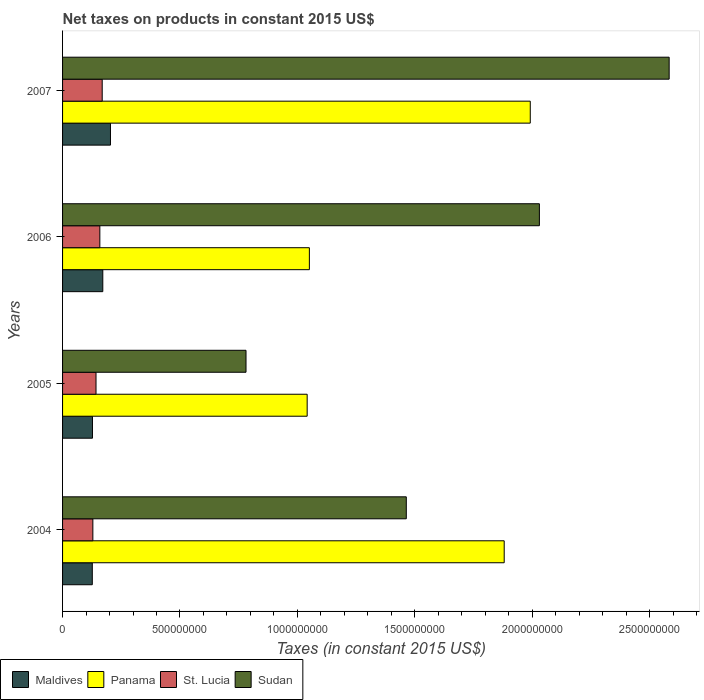How many groups of bars are there?
Your answer should be very brief. 4. Are the number of bars on each tick of the Y-axis equal?
Your response must be concise. Yes. In how many cases, is the number of bars for a given year not equal to the number of legend labels?
Make the answer very short. 0. What is the net taxes on products in St. Lucia in 2004?
Provide a short and direct response. 1.29e+08. Across all years, what is the maximum net taxes on products in Panama?
Provide a succinct answer. 1.99e+09. Across all years, what is the minimum net taxes on products in St. Lucia?
Keep it short and to the point. 1.29e+08. In which year was the net taxes on products in Panama maximum?
Your answer should be compact. 2007. What is the total net taxes on products in Panama in the graph?
Keep it short and to the point. 5.97e+09. What is the difference between the net taxes on products in Panama in 2005 and that in 2007?
Offer a terse response. -9.50e+08. What is the difference between the net taxes on products in Panama in 2006 and the net taxes on products in Maldives in 2005?
Keep it short and to the point. 9.24e+08. What is the average net taxes on products in Panama per year?
Your answer should be compact. 1.49e+09. In the year 2005, what is the difference between the net taxes on products in Panama and net taxes on products in St. Lucia?
Your answer should be compact. 8.99e+08. In how many years, is the net taxes on products in Panama greater than 400000000 US$?
Keep it short and to the point. 4. What is the ratio of the net taxes on products in St. Lucia in 2004 to that in 2006?
Offer a terse response. 0.81. Is the difference between the net taxes on products in Panama in 2004 and 2006 greater than the difference between the net taxes on products in St. Lucia in 2004 and 2006?
Give a very brief answer. Yes. What is the difference between the highest and the second highest net taxes on products in Panama?
Provide a short and direct response. 1.11e+08. What is the difference between the highest and the lowest net taxes on products in St. Lucia?
Give a very brief answer. 3.98e+07. Is the sum of the net taxes on products in Panama in 2004 and 2006 greater than the maximum net taxes on products in Sudan across all years?
Your answer should be compact. Yes. What does the 4th bar from the top in 2004 represents?
Provide a short and direct response. Maldives. What does the 1st bar from the bottom in 2006 represents?
Offer a terse response. Maldives. How many bars are there?
Give a very brief answer. 16. Are all the bars in the graph horizontal?
Provide a short and direct response. Yes. What is the difference between two consecutive major ticks on the X-axis?
Your answer should be compact. 5.00e+08. Are the values on the major ticks of X-axis written in scientific E-notation?
Offer a terse response. No. Where does the legend appear in the graph?
Your answer should be compact. Bottom left. How are the legend labels stacked?
Ensure brevity in your answer.  Horizontal. What is the title of the graph?
Provide a succinct answer. Net taxes on products in constant 2015 US$. Does "Mali" appear as one of the legend labels in the graph?
Make the answer very short. No. What is the label or title of the X-axis?
Your answer should be very brief. Taxes (in constant 2015 US$). What is the label or title of the Y-axis?
Keep it short and to the point. Years. What is the Taxes (in constant 2015 US$) in Maldives in 2004?
Provide a succinct answer. 1.27e+08. What is the Taxes (in constant 2015 US$) of Panama in 2004?
Your response must be concise. 1.88e+09. What is the Taxes (in constant 2015 US$) of St. Lucia in 2004?
Provide a succinct answer. 1.29e+08. What is the Taxes (in constant 2015 US$) of Sudan in 2004?
Keep it short and to the point. 1.46e+09. What is the Taxes (in constant 2015 US$) in Maldives in 2005?
Provide a succinct answer. 1.27e+08. What is the Taxes (in constant 2015 US$) in Panama in 2005?
Offer a terse response. 1.04e+09. What is the Taxes (in constant 2015 US$) in St. Lucia in 2005?
Offer a very short reply. 1.42e+08. What is the Taxes (in constant 2015 US$) in Sudan in 2005?
Your answer should be very brief. 7.81e+08. What is the Taxes (in constant 2015 US$) of Maldives in 2006?
Keep it short and to the point. 1.71e+08. What is the Taxes (in constant 2015 US$) in Panama in 2006?
Provide a short and direct response. 1.05e+09. What is the Taxes (in constant 2015 US$) in St. Lucia in 2006?
Keep it short and to the point. 1.59e+08. What is the Taxes (in constant 2015 US$) of Sudan in 2006?
Offer a very short reply. 2.03e+09. What is the Taxes (in constant 2015 US$) of Maldives in 2007?
Your answer should be very brief. 2.04e+08. What is the Taxes (in constant 2015 US$) in Panama in 2007?
Your answer should be very brief. 1.99e+09. What is the Taxes (in constant 2015 US$) in St. Lucia in 2007?
Your answer should be very brief. 1.69e+08. What is the Taxes (in constant 2015 US$) of Sudan in 2007?
Your answer should be very brief. 2.58e+09. Across all years, what is the maximum Taxes (in constant 2015 US$) of Maldives?
Your answer should be very brief. 2.04e+08. Across all years, what is the maximum Taxes (in constant 2015 US$) of Panama?
Provide a succinct answer. 1.99e+09. Across all years, what is the maximum Taxes (in constant 2015 US$) of St. Lucia?
Keep it short and to the point. 1.69e+08. Across all years, what is the maximum Taxes (in constant 2015 US$) of Sudan?
Your answer should be very brief. 2.58e+09. Across all years, what is the minimum Taxes (in constant 2015 US$) in Maldives?
Offer a very short reply. 1.27e+08. Across all years, what is the minimum Taxes (in constant 2015 US$) in Panama?
Your response must be concise. 1.04e+09. Across all years, what is the minimum Taxes (in constant 2015 US$) of St. Lucia?
Give a very brief answer. 1.29e+08. Across all years, what is the minimum Taxes (in constant 2015 US$) in Sudan?
Offer a very short reply. 7.81e+08. What is the total Taxes (in constant 2015 US$) of Maldives in the graph?
Your response must be concise. 6.29e+08. What is the total Taxes (in constant 2015 US$) of Panama in the graph?
Your answer should be compact. 5.97e+09. What is the total Taxes (in constant 2015 US$) of St. Lucia in the graph?
Provide a short and direct response. 5.99e+08. What is the total Taxes (in constant 2015 US$) of Sudan in the graph?
Your answer should be very brief. 6.86e+09. What is the difference between the Taxes (in constant 2015 US$) in Maldives in 2004 and that in 2005?
Give a very brief answer. -6.98e+05. What is the difference between the Taxes (in constant 2015 US$) in Panama in 2004 and that in 2005?
Offer a very short reply. 8.39e+08. What is the difference between the Taxes (in constant 2015 US$) of St. Lucia in 2004 and that in 2005?
Keep it short and to the point. -1.35e+07. What is the difference between the Taxes (in constant 2015 US$) of Sudan in 2004 and that in 2005?
Give a very brief answer. 6.83e+08. What is the difference between the Taxes (in constant 2015 US$) in Maldives in 2004 and that in 2006?
Your answer should be compact. -4.47e+07. What is the difference between the Taxes (in constant 2015 US$) of Panama in 2004 and that in 2006?
Your response must be concise. 8.30e+08. What is the difference between the Taxes (in constant 2015 US$) of St. Lucia in 2004 and that in 2006?
Offer a very short reply. -2.98e+07. What is the difference between the Taxes (in constant 2015 US$) in Sudan in 2004 and that in 2006?
Provide a succinct answer. -5.67e+08. What is the difference between the Taxes (in constant 2015 US$) of Maldives in 2004 and that in 2007?
Offer a terse response. -7.74e+07. What is the difference between the Taxes (in constant 2015 US$) in Panama in 2004 and that in 2007?
Make the answer very short. -1.11e+08. What is the difference between the Taxes (in constant 2015 US$) of St. Lucia in 2004 and that in 2007?
Your answer should be very brief. -3.98e+07. What is the difference between the Taxes (in constant 2015 US$) in Sudan in 2004 and that in 2007?
Make the answer very short. -1.12e+09. What is the difference between the Taxes (in constant 2015 US$) of Maldives in 2005 and that in 2006?
Offer a very short reply. -4.40e+07. What is the difference between the Taxes (in constant 2015 US$) of Panama in 2005 and that in 2006?
Your answer should be very brief. -9.40e+06. What is the difference between the Taxes (in constant 2015 US$) of St. Lucia in 2005 and that in 2006?
Your response must be concise. -1.63e+07. What is the difference between the Taxes (in constant 2015 US$) in Sudan in 2005 and that in 2006?
Your answer should be very brief. -1.25e+09. What is the difference between the Taxes (in constant 2015 US$) in Maldives in 2005 and that in 2007?
Offer a terse response. -7.67e+07. What is the difference between the Taxes (in constant 2015 US$) in Panama in 2005 and that in 2007?
Provide a succinct answer. -9.50e+08. What is the difference between the Taxes (in constant 2015 US$) of St. Lucia in 2005 and that in 2007?
Provide a succinct answer. -2.63e+07. What is the difference between the Taxes (in constant 2015 US$) of Sudan in 2005 and that in 2007?
Keep it short and to the point. -1.80e+09. What is the difference between the Taxes (in constant 2015 US$) in Maldives in 2006 and that in 2007?
Give a very brief answer. -3.27e+07. What is the difference between the Taxes (in constant 2015 US$) in Panama in 2006 and that in 2007?
Your answer should be very brief. -9.41e+08. What is the difference between the Taxes (in constant 2015 US$) in St. Lucia in 2006 and that in 2007?
Offer a terse response. -1.01e+07. What is the difference between the Taxes (in constant 2015 US$) in Sudan in 2006 and that in 2007?
Offer a terse response. -5.53e+08. What is the difference between the Taxes (in constant 2015 US$) of Maldives in 2004 and the Taxes (in constant 2015 US$) of Panama in 2005?
Ensure brevity in your answer.  -9.15e+08. What is the difference between the Taxes (in constant 2015 US$) of Maldives in 2004 and the Taxes (in constant 2015 US$) of St. Lucia in 2005?
Keep it short and to the point. -1.59e+07. What is the difference between the Taxes (in constant 2015 US$) in Maldives in 2004 and the Taxes (in constant 2015 US$) in Sudan in 2005?
Offer a very short reply. -6.55e+08. What is the difference between the Taxes (in constant 2015 US$) of Panama in 2004 and the Taxes (in constant 2015 US$) of St. Lucia in 2005?
Make the answer very short. 1.74e+09. What is the difference between the Taxes (in constant 2015 US$) of Panama in 2004 and the Taxes (in constant 2015 US$) of Sudan in 2005?
Provide a short and direct response. 1.10e+09. What is the difference between the Taxes (in constant 2015 US$) of St. Lucia in 2004 and the Taxes (in constant 2015 US$) of Sudan in 2005?
Your answer should be compact. -6.52e+08. What is the difference between the Taxes (in constant 2015 US$) in Maldives in 2004 and the Taxes (in constant 2015 US$) in Panama in 2006?
Offer a terse response. -9.25e+08. What is the difference between the Taxes (in constant 2015 US$) of Maldives in 2004 and the Taxes (in constant 2015 US$) of St. Lucia in 2006?
Keep it short and to the point. -3.21e+07. What is the difference between the Taxes (in constant 2015 US$) in Maldives in 2004 and the Taxes (in constant 2015 US$) in Sudan in 2006?
Your answer should be compact. -1.90e+09. What is the difference between the Taxes (in constant 2015 US$) of Panama in 2004 and the Taxes (in constant 2015 US$) of St. Lucia in 2006?
Give a very brief answer. 1.72e+09. What is the difference between the Taxes (in constant 2015 US$) in Panama in 2004 and the Taxes (in constant 2015 US$) in Sudan in 2006?
Your answer should be compact. -1.50e+08. What is the difference between the Taxes (in constant 2015 US$) of St. Lucia in 2004 and the Taxes (in constant 2015 US$) of Sudan in 2006?
Provide a short and direct response. -1.90e+09. What is the difference between the Taxes (in constant 2015 US$) of Maldives in 2004 and the Taxes (in constant 2015 US$) of Panama in 2007?
Your answer should be compact. -1.87e+09. What is the difference between the Taxes (in constant 2015 US$) of Maldives in 2004 and the Taxes (in constant 2015 US$) of St. Lucia in 2007?
Offer a terse response. -4.22e+07. What is the difference between the Taxes (in constant 2015 US$) of Maldives in 2004 and the Taxes (in constant 2015 US$) of Sudan in 2007?
Offer a terse response. -2.46e+09. What is the difference between the Taxes (in constant 2015 US$) of Panama in 2004 and the Taxes (in constant 2015 US$) of St. Lucia in 2007?
Provide a succinct answer. 1.71e+09. What is the difference between the Taxes (in constant 2015 US$) of Panama in 2004 and the Taxes (in constant 2015 US$) of Sudan in 2007?
Your answer should be very brief. -7.03e+08. What is the difference between the Taxes (in constant 2015 US$) of St. Lucia in 2004 and the Taxes (in constant 2015 US$) of Sudan in 2007?
Provide a succinct answer. -2.45e+09. What is the difference between the Taxes (in constant 2015 US$) of Maldives in 2005 and the Taxes (in constant 2015 US$) of Panama in 2006?
Offer a very short reply. -9.24e+08. What is the difference between the Taxes (in constant 2015 US$) in Maldives in 2005 and the Taxes (in constant 2015 US$) in St. Lucia in 2006?
Offer a very short reply. -3.14e+07. What is the difference between the Taxes (in constant 2015 US$) in Maldives in 2005 and the Taxes (in constant 2015 US$) in Sudan in 2006?
Keep it short and to the point. -1.90e+09. What is the difference between the Taxes (in constant 2015 US$) in Panama in 2005 and the Taxes (in constant 2015 US$) in St. Lucia in 2006?
Offer a terse response. 8.83e+08. What is the difference between the Taxes (in constant 2015 US$) in Panama in 2005 and the Taxes (in constant 2015 US$) in Sudan in 2006?
Your response must be concise. -9.89e+08. What is the difference between the Taxes (in constant 2015 US$) of St. Lucia in 2005 and the Taxes (in constant 2015 US$) of Sudan in 2006?
Make the answer very short. -1.89e+09. What is the difference between the Taxes (in constant 2015 US$) in Maldives in 2005 and the Taxes (in constant 2015 US$) in Panama in 2007?
Your response must be concise. -1.86e+09. What is the difference between the Taxes (in constant 2015 US$) in Maldives in 2005 and the Taxes (in constant 2015 US$) in St. Lucia in 2007?
Provide a succinct answer. -4.15e+07. What is the difference between the Taxes (in constant 2015 US$) of Maldives in 2005 and the Taxes (in constant 2015 US$) of Sudan in 2007?
Ensure brevity in your answer.  -2.46e+09. What is the difference between the Taxes (in constant 2015 US$) of Panama in 2005 and the Taxes (in constant 2015 US$) of St. Lucia in 2007?
Provide a succinct answer. 8.73e+08. What is the difference between the Taxes (in constant 2015 US$) in Panama in 2005 and the Taxes (in constant 2015 US$) in Sudan in 2007?
Your answer should be compact. -1.54e+09. What is the difference between the Taxes (in constant 2015 US$) in St. Lucia in 2005 and the Taxes (in constant 2015 US$) in Sudan in 2007?
Ensure brevity in your answer.  -2.44e+09. What is the difference between the Taxes (in constant 2015 US$) in Maldives in 2006 and the Taxes (in constant 2015 US$) in Panama in 2007?
Make the answer very short. -1.82e+09. What is the difference between the Taxes (in constant 2015 US$) in Maldives in 2006 and the Taxes (in constant 2015 US$) in St. Lucia in 2007?
Your answer should be compact. 2.49e+06. What is the difference between the Taxes (in constant 2015 US$) in Maldives in 2006 and the Taxes (in constant 2015 US$) in Sudan in 2007?
Give a very brief answer. -2.41e+09. What is the difference between the Taxes (in constant 2015 US$) in Panama in 2006 and the Taxes (in constant 2015 US$) in St. Lucia in 2007?
Provide a short and direct response. 8.82e+08. What is the difference between the Taxes (in constant 2015 US$) in Panama in 2006 and the Taxes (in constant 2015 US$) in Sudan in 2007?
Your answer should be very brief. -1.53e+09. What is the difference between the Taxes (in constant 2015 US$) in St. Lucia in 2006 and the Taxes (in constant 2015 US$) in Sudan in 2007?
Your response must be concise. -2.42e+09. What is the average Taxes (in constant 2015 US$) of Maldives per year?
Your response must be concise. 1.57e+08. What is the average Taxes (in constant 2015 US$) of Panama per year?
Offer a very short reply. 1.49e+09. What is the average Taxes (in constant 2015 US$) in St. Lucia per year?
Provide a short and direct response. 1.50e+08. What is the average Taxes (in constant 2015 US$) of Sudan per year?
Provide a succinct answer. 1.71e+09. In the year 2004, what is the difference between the Taxes (in constant 2015 US$) of Maldives and Taxes (in constant 2015 US$) of Panama?
Provide a succinct answer. -1.75e+09. In the year 2004, what is the difference between the Taxes (in constant 2015 US$) in Maldives and Taxes (in constant 2015 US$) in St. Lucia?
Your answer should be compact. -2.38e+06. In the year 2004, what is the difference between the Taxes (in constant 2015 US$) in Maldives and Taxes (in constant 2015 US$) in Sudan?
Your response must be concise. -1.34e+09. In the year 2004, what is the difference between the Taxes (in constant 2015 US$) of Panama and Taxes (in constant 2015 US$) of St. Lucia?
Offer a very short reply. 1.75e+09. In the year 2004, what is the difference between the Taxes (in constant 2015 US$) of Panama and Taxes (in constant 2015 US$) of Sudan?
Your answer should be compact. 4.17e+08. In the year 2004, what is the difference between the Taxes (in constant 2015 US$) in St. Lucia and Taxes (in constant 2015 US$) in Sudan?
Ensure brevity in your answer.  -1.34e+09. In the year 2005, what is the difference between the Taxes (in constant 2015 US$) in Maldives and Taxes (in constant 2015 US$) in Panama?
Offer a very short reply. -9.14e+08. In the year 2005, what is the difference between the Taxes (in constant 2015 US$) in Maldives and Taxes (in constant 2015 US$) in St. Lucia?
Offer a very short reply. -1.52e+07. In the year 2005, what is the difference between the Taxes (in constant 2015 US$) of Maldives and Taxes (in constant 2015 US$) of Sudan?
Your answer should be very brief. -6.54e+08. In the year 2005, what is the difference between the Taxes (in constant 2015 US$) of Panama and Taxes (in constant 2015 US$) of St. Lucia?
Offer a terse response. 8.99e+08. In the year 2005, what is the difference between the Taxes (in constant 2015 US$) in Panama and Taxes (in constant 2015 US$) in Sudan?
Offer a terse response. 2.60e+08. In the year 2005, what is the difference between the Taxes (in constant 2015 US$) of St. Lucia and Taxes (in constant 2015 US$) of Sudan?
Provide a short and direct response. -6.39e+08. In the year 2006, what is the difference between the Taxes (in constant 2015 US$) of Maldives and Taxes (in constant 2015 US$) of Panama?
Offer a very short reply. -8.80e+08. In the year 2006, what is the difference between the Taxes (in constant 2015 US$) in Maldives and Taxes (in constant 2015 US$) in St. Lucia?
Provide a short and direct response. 1.25e+07. In the year 2006, what is the difference between the Taxes (in constant 2015 US$) of Maldives and Taxes (in constant 2015 US$) of Sudan?
Make the answer very short. -1.86e+09. In the year 2006, what is the difference between the Taxes (in constant 2015 US$) of Panama and Taxes (in constant 2015 US$) of St. Lucia?
Make the answer very short. 8.92e+08. In the year 2006, what is the difference between the Taxes (in constant 2015 US$) in Panama and Taxes (in constant 2015 US$) in Sudan?
Provide a short and direct response. -9.80e+08. In the year 2006, what is the difference between the Taxes (in constant 2015 US$) of St. Lucia and Taxes (in constant 2015 US$) of Sudan?
Provide a succinct answer. -1.87e+09. In the year 2007, what is the difference between the Taxes (in constant 2015 US$) in Maldives and Taxes (in constant 2015 US$) in Panama?
Provide a short and direct response. -1.79e+09. In the year 2007, what is the difference between the Taxes (in constant 2015 US$) of Maldives and Taxes (in constant 2015 US$) of St. Lucia?
Provide a succinct answer. 3.52e+07. In the year 2007, what is the difference between the Taxes (in constant 2015 US$) in Maldives and Taxes (in constant 2015 US$) in Sudan?
Offer a terse response. -2.38e+09. In the year 2007, what is the difference between the Taxes (in constant 2015 US$) of Panama and Taxes (in constant 2015 US$) of St. Lucia?
Offer a very short reply. 1.82e+09. In the year 2007, what is the difference between the Taxes (in constant 2015 US$) in Panama and Taxes (in constant 2015 US$) in Sudan?
Make the answer very short. -5.92e+08. In the year 2007, what is the difference between the Taxes (in constant 2015 US$) in St. Lucia and Taxes (in constant 2015 US$) in Sudan?
Provide a succinct answer. -2.41e+09. What is the ratio of the Taxes (in constant 2015 US$) of Panama in 2004 to that in 2005?
Your response must be concise. 1.81. What is the ratio of the Taxes (in constant 2015 US$) of St. Lucia in 2004 to that in 2005?
Your answer should be compact. 0.91. What is the ratio of the Taxes (in constant 2015 US$) in Sudan in 2004 to that in 2005?
Provide a short and direct response. 1.87. What is the ratio of the Taxes (in constant 2015 US$) of Maldives in 2004 to that in 2006?
Your answer should be compact. 0.74. What is the ratio of the Taxes (in constant 2015 US$) of Panama in 2004 to that in 2006?
Provide a succinct answer. 1.79. What is the ratio of the Taxes (in constant 2015 US$) in St. Lucia in 2004 to that in 2006?
Your response must be concise. 0.81. What is the ratio of the Taxes (in constant 2015 US$) of Sudan in 2004 to that in 2006?
Your answer should be compact. 0.72. What is the ratio of the Taxes (in constant 2015 US$) in Maldives in 2004 to that in 2007?
Offer a very short reply. 0.62. What is the ratio of the Taxes (in constant 2015 US$) of Panama in 2004 to that in 2007?
Ensure brevity in your answer.  0.94. What is the ratio of the Taxes (in constant 2015 US$) in St. Lucia in 2004 to that in 2007?
Provide a short and direct response. 0.76. What is the ratio of the Taxes (in constant 2015 US$) of Sudan in 2004 to that in 2007?
Provide a short and direct response. 0.57. What is the ratio of the Taxes (in constant 2015 US$) of Maldives in 2005 to that in 2006?
Ensure brevity in your answer.  0.74. What is the ratio of the Taxes (in constant 2015 US$) in St. Lucia in 2005 to that in 2006?
Provide a short and direct response. 0.9. What is the ratio of the Taxes (in constant 2015 US$) of Sudan in 2005 to that in 2006?
Provide a succinct answer. 0.38. What is the ratio of the Taxes (in constant 2015 US$) in Maldives in 2005 to that in 2007?
Give a very brief answer. 0.62. What is the ratio of the Taxes (in constant 2015 US$) of Panama in 2005 to that in 2007?
Your answer should be very brief. 0.52. What is the ratio of the Taxes (in constant 2015 US$) of St. Lucia in 2005 to that in 2007?
Offer a very short reply. 0.84. What is the ratio of the Taxes (in constant 2015 US$) in Sudan in 2005 to that in 2007?
Provide a short and direct response. 0.3. What is the ratio of the Taxes (in constant 2015 US$) in Maldives in 2006 to that in 2007?
Your answer should be compact. 0.84. What is the ratio of the Taxes (in constant 2015 US$) in Panama in 2006 to that in 2007?
Provide a short and direct response. 0.53. What is the ratio of the Taxes (in constant 2015 US$) in St. Lucia in 2006 to that in 2007?
Offer a terse response. 0.94. What is the ratio of the Taxes (in constant 2015 US$) in Sudan in 2006 to that in 2007?
Provide a short and direct response. 0.79. What is the difference between the highest and the second highest Taxes (in constant 2015 US$) of Maldives?
Offer a terse response. 3.27e+07. What is the difference between the highest and the second highest Taxes (in constant 2015 US$) in Panama?
Your response must be concise. 1.11e+08. What is the difference between the highest and the second highest Taxes (in constant 2015 US$) in St. Lucia?
Offer a very short reply. 1.01e+07. What is the difference between the highest and the second highest Taxes (in constant 2015 US$) in Sudan?
Give a very brief answer. 5.53e+08. What is the difference between the highest and the lowest Taxes (in constant 2015 US$) in Maldives?
Keep it short and to the point. 7.74e+07. What is the difference between the highest and the lowest Taxes (in constant 2015 US$) of Panama?
Give a very brief answer. 9.50e+08. What is the difference between the highest and the lowest Taxes (in constant 2015 US$) in St. Lucia?
Make the answer very short. 3.98e+07. What is the difference between the highest and the lowest Taxes (in constant 2015 US$) of Sudan?
Offer a very short reply. 1.80e+09. 